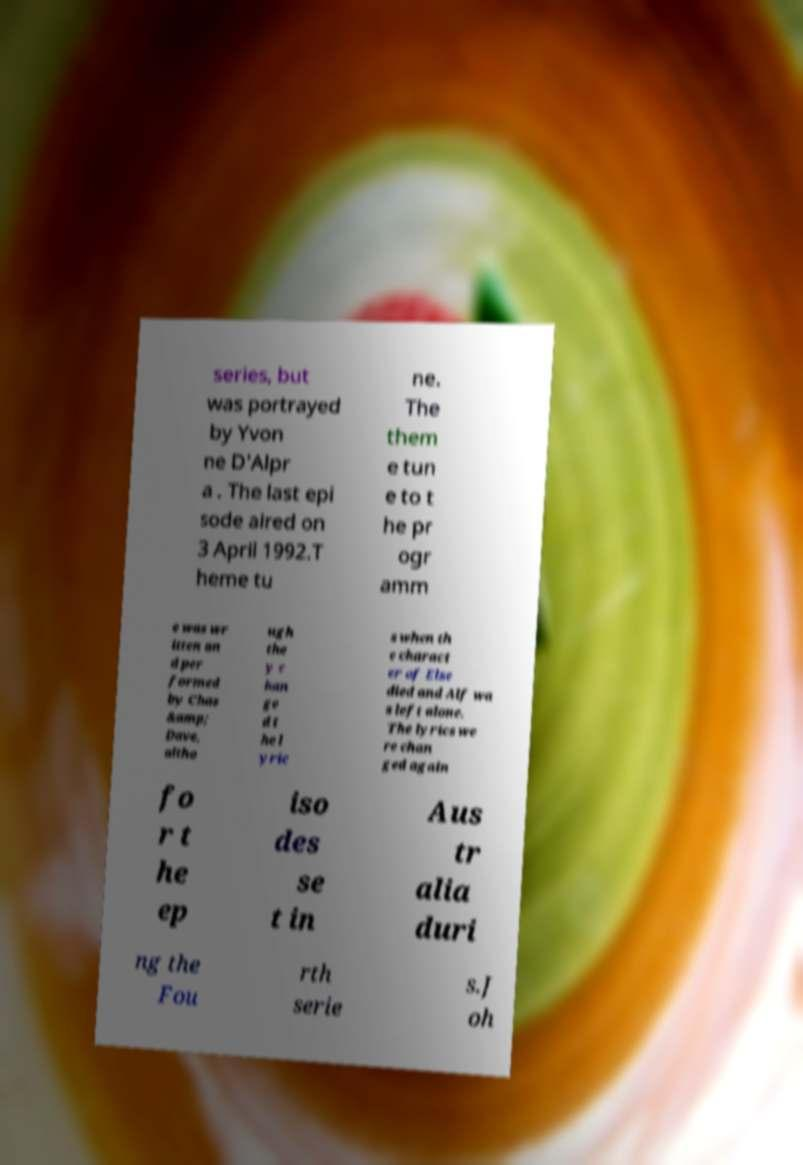I need the written content from this picture converted into text. Can you do that? series, but was portrayed by Yvon ne D'Alpr a . The last epi sode aired on 3 April 1992.T heme tu ne. The them e tun e to t he pr ogr amm e was wr itten an d per formed by Chas &amp; Dave, altho ugh the y c han ge d t he l yric s when th e charact er of Else died and Alf wa s left alone. The lyrics we re chan ged again fo r t he ep iso des se t in Aus tr alia duri ng the Fou rth serie s.J oh 